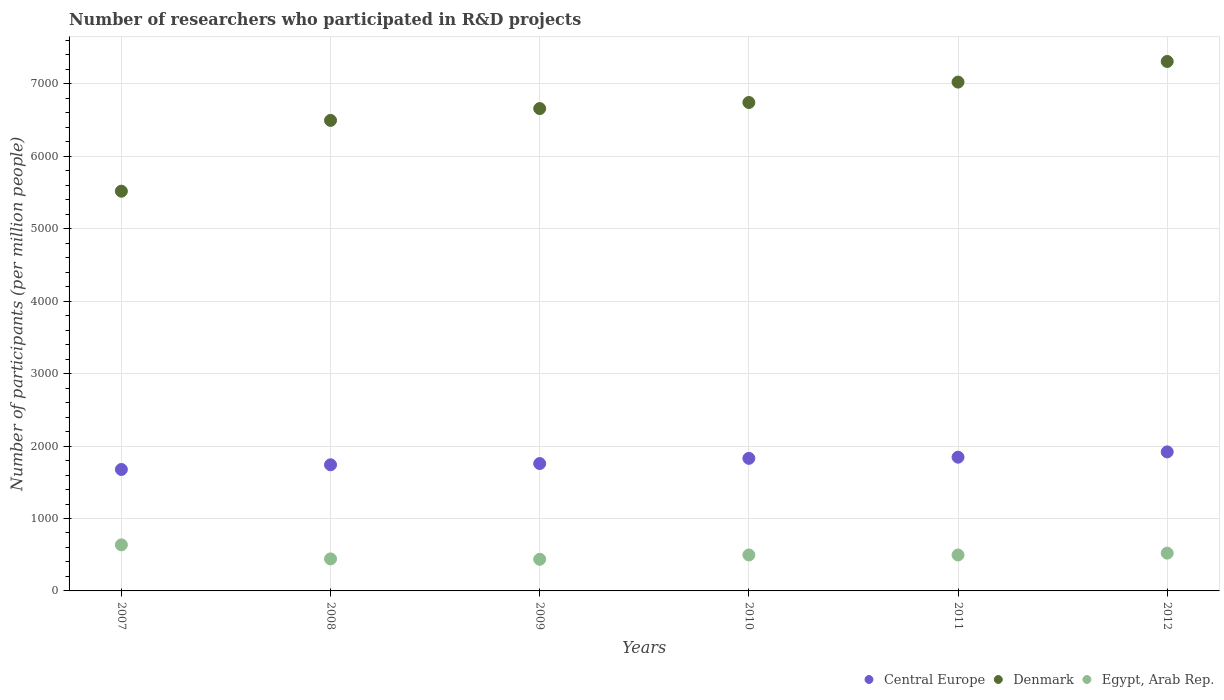Is the number of dotlines equal to the number of legend labels?
Make the answer very short. Yes. What is the number of researchers who participated in R&D projects in Denmark in 2012?
Your response must be concise. 7310.52. Across all years, what is the maximum number of researchers who participated in R&D projects in Denmark?
Provide a short and direct response. 7310.52. Across all years, what is the minimum number of researchers who participated in R&D projects in Denmark?
Give a very brief answer. 5519.32. What is the total number of researchers who participated in R&D projects in Central Europe in the graph?
Ensure brevity in your answer.  1.08e+04. What is the difference between the number of researchers who participated in R&D projects in Egypt, Arab Rep. in 2007 and that in 2009?
Provide a short and direct response. 199.02. What is the difference between the number of researchers who participated in R&D projects in Egypt, Arab Rep. in 2009 and the number of researchers who participated in R&D projects in Central Europe in 2010?
Ensure brevity in your answer.  -1393.5. What is the average number of researchers who participated in R&D projects in Egypt, Arab Rep. per year?
Offer a terse response. 505. In the year 2010, what is the difference between the number of researchers who participated in R&D projects in Central Europe and number of researchers who participated in R&D projects in Egypt, Arab Rep.?
Your answer should be compact. 1333.83. What is the ratio of the number of researchers who participated in R&D projects in Central Europe in 2009 to that in 2011?
Provide a short and direct response. 0.95. What is the difference between the highest and the second highest number of researchers who participated in R&D projects in Egypt, Arab Rep.?
Your answer should be very brief. 114.34. What is the difference between the highest and the lowest number of researchers who participated in R&D projects in Central Europe?
Your response must be concise. 242.64. In how many years, is the number of researchers who participated in R&D projects in Egypt, Arab Rep. greater than the average number of researchers who participated in R&D projects in Egypt, Arab Rep. taken over all years?
Offer a very short reply. 2. Is the sum of the number of researchers who participated in R&D projects in Egypt, Arab Rep. in 2007 and 2011 greater than the maximum number of researchers who participated in R&D projects in Denmark across all years?
Offer a very short reply. No. Is it the case that in every year, the sum of the number of researchers who participated in R&D projects in Egypt, Arab Rep. and number of researchers who participated in R&D projects in Central Europe  is greater than the number of researchers who participated in R&D projects in Denmark?
Your response must be concise. No. Is the number of researchers who participated in R&D projects in Central Europe strictly less than the number of researchers who participated in R&D projects in Denmark over the years?
Your answer should be very brief. Yes. How many dotlines are there?
Offer a very short reply. 3. How many years are there in the graph?
Offer a very short reply. 6. What is the difference between two consecutive major ticks on the Y-axis?
Ensure brevity in your answer.  1000. Does the graph contain grids?
Your response must be concise. Yes. Where does the legend appear in the graph?
Make the answer very short. Bottom right. How are the legend labels stacked?
Make the answer very short. Horizontal. What is the title of the graph?
Offer a very short reply. Number of researchers who participated in R&D projects. Does "Romania" appear as one of the legend labels in the graph?
Give a very brief answer. No. What is the label or title of the Y-axis?
Offer a terse response. Number of participants (per million people). What is the Number of participants (per million people) of Central Europe in 2007?
Your answer should be compact. 1676.99. What is the Number of participants (per million people) of Denmark in 2007?
Offer a terse response. 5519.32. What is the Number of participants (per million people) in Egypt, Arab Rep. in 2007?
Offer a very short reply. 636.08. What is the Number of participants (per million people) of Central Europe in 2008?
Your response must be concise. 1741.84. What is the Number of participants (per million people) of Denmark in 2008?
Offer a terse response. 6496.76. What is the Number of participants (per million people) in Egypt, Arab Rep. in 2008?
Provide a succinct answer. 442.27. What is the Number of participants (per million people) in Central Europe in 2009?
Your response must be concise. 1758.57. What is the Number of participants (per million people) of Denmark in 2009?
Make the answer very short. 6660.14. What is the Number of participants (per million people) of Egypt, Arab Rep. in 2009?
Keep it short and to the point. 437.06. What is the Number of participants (per million people) of Central Europe in 2010?
Make the answer very short. 1830.56. What is the Number of participants (per million people) in Denmark in 2010?
Give a very brief answer. 6743.9. What is the Number of participants (per million people) of Egypt, Arab Rep. in 2010?
Your answer should be very brief. 496.73. What is the Number of participants (per million people) in Central Europe in 2011?
Your response must be concise. 1846.65. What is the Number of participants (per million people) in Denmark in 2011?
Your response must be concise. 7025.82. What is the Number of participants (per million people) in Egypt, Arab Rep. in 2011?
Your answer should be very brief. 496.12. What is the Number of participants (per million people) of Central Europe in 2012?
Your answer should be very brief. 1919.63. What is the Number of participants (per million people) of Denmark in 2012?
Provide a succinct answer. 7310.52. What is the Number of participants (per million people) of Egypt, Arab Rep. in 2012?
Provide a short and direct response. 521.74. Across all years, what is the maximum Number of participants (per million people) of Central Europe?
Provide a short and direct response. 1919.63. Across all years, what is the maximum Number of participants (per million people) in Denmark?
Provide a short and direct response. 7310.52. Across all years, what is the maximum Number of participants (per million people) of Egypt, Arab Rep.?
Your answer should be very brief. 636.08. Across all years, what is the minimum Number of participants (per million people) of Central Europe?
Keep it short and to the point. 1676.99. Across all years, what is the minimum Number of participants (per million people) in Denmark?
Offer a very short reply. 5519.32. Across all years, what is the minimum Number of participants (per million people) in Egypt, Arab Rep.?
Provide a short and direct response. 437.06. What is the total Number of participants (per million people) of Central Europe in the graph?
Ensure brevity in your answer.  1.08e+04. What is the total Number of participants (per million people) of Denmark in the graph?
Provide a succinct answer. 3.98e+04. What is the total Number of participants (per million people) of Egypt, Arab Rep. in the graph?
Ensure brevity in your answer.  3029.99. What is the difference between the Number of participants (per million people) of Central Europe in 2007 and that in 2008?
Your answer should be very brief. -64.85. What is the difference between the Number of participants (per million people) in Denmark in 2007 and that in 2008?
Your answer should be compact. -977.45. What is the difference between the Number of participants (per million people) in Egypt, Arab Rep. in 2007 and that in 2008?
Ensure brevity in your answer.  193.81. What is the difference between the Number of participants (per million people) of Central Europe in 2007 and that in 2009?
Provide a succinct answer. -81.58. What is the difference between the Number of participants (per million people) of Denmark in 2007 and that in 2009?
Your answer should be compact. -1140.83. What is the difference between the Number of participants (per million people) in Egypt, Arab Rep. in 2007 and that in 2009?
Provide a short and direct response. 199.02. What is the difference between the Number of participants (per million people) of Central Europe in 2007 and that in 2010?
Ensure brevity in your answer.  -153.57. What is the difference between the Number of participants (per million people) of Denmark in 2007 and that in 2010?
Ensure brevity in your answer.  -1224.58. What is the difference between the Number of participants (per million people) of Egypt, Arab Rep. in 2007 and that in 2010?
Your response must be concise. 139.35. What is the difference between the Number of participants (per million people) of Central Europe in 2007 and that in 2011?
Ensure brevity in your answer.  -169.66. What is the difference between the Number of participants (per million people) of Denmark in 2007 and that in 2011?
Your answer should be very brief. -1506.5. What is the difference between the Number of participants (per million people) in Egypt, Arab Rep. in 2007 and that in 2011?
Your answer should be very brief. 139.96. What is the difference between the Number of participants (per million people) in Central Europe in 2007 and that in 2012?
Make the answer very short. -242.64. What is the difference between the Number of participants (per million people) in Denmark in 2007 and that in 2012?
Your answer should be compact. -1791.2. What is the difference between the Number of participants (per million people) in Egypt, Arab Rep. in 2007 and that in 2012?
Your answer should be very brief. 114.34. What is the difference between the Number of participants (per million people) in Central Europe in 2008 and that in 2009?
Ensure brevity in your answer.  -16.73. What is the difference between the Number of participants (per million people) of Denmark in 2008 and that in 2009?
Your response must be concise. -163.38. What is the difference between the Number of participants (per million people) of Egypt, Arab Rep. in 2008 and that in 2009?
Offer a terse response. 5.21. What is the difference between the Number of participants (per million people) of Central Europe in 2008 and that in 2010?
Offer a terse response. -88.71. What is the difference between the Number of participants (per million people) of Denmark in 2008 and that in 2010?
Your answer should be very brief. -247.13. What is the difference between the Number of participants (per million people) of Egypt, Arab Rep. in 2008 and that in 2010?
Your answer should be very brief. -54.46. What is the difference between the Number of participants (per million people) of Central Europe in 2008 and that in 2011?
Your response must be concise. -104.8. What is the difference between the Number of participants (per million people) in Denmark in 2008 and that in 2011?
Offer a terse response. -529.05. What is the difference between the Number of participants (per million people) in Egypt, Arab Rep. in 2008 and that in 2011?
Keep it short and to the point. -53.85. What is the difference between the Number of participants (per million people) in Central Europe in 2008 and that in 2012?
Provide a succinct answer. -177.79. What is the difference between the Number of participants (per million people) in Denmark in 2008 and that in 2012?
Provide a succinct answer. -813.75. What is the difference between the Number of participants (per million people) in Egypt, Arab Rep. in 2008 and that in 2012?
Keep it short and to the point. -79.47. What is the difference between the Number of participants (per million people) of Central Europe in 2009 and that in 2010?
Your answer should be compact. -71.98. What is the difference between the Number of participants (per million people) of Denmark in 2009 and that in 2010?
Your answer should be very brief. -83.75. What is the difference between the Number of participants (per million people) of Egypt, Arab Rep. in 2009 and that in 2010?
Keep it short and to the point. -59.67. What is the difference between the Number of participants (per million people) in Central Europe in 2009 and that in 2011?
Offer a terse response. -88.07. What is the difference between the Number of participants (per million people) of Denmark in 2009 and that in 2011?
Make the answer very short. -365.67. What is the difference between the Number of participants (per million people) of Egypt, Arab Rep. in 2009 and that in 2011?
Ensure brevity in your answer.  -59.06. What is the difference between the Number of participants (per million people) in Central Europe in 2009 and that in 2012?
Ensure brevity in your answer.  -161.06. What is the difference between the Number of participants (per million people) in Denmark in 2009 and that in 2012?
Provide a short and direct response. -650.37. What is the difference between the Number of participants (per million people) of Egypt, Arab Rep. in 2009 and that in 2012?
Ensure brevity in your answer.  -84.68. What is the difference between the Number of participants (per million people) in Central Europe in 2010 and that in 2011?
Make the answer very short. -16.09. What is the difference between the Number of participants (per million people) in Denmark in 2010 and that in 2011?
Give a very brief answer. -281.92. What is the difference between the Number of participants (per million people) in Egypt, Arab Rep. in 2010 and that in 2011?
Ensure brevity in your answer.  0.61. What is the difference between the Number of participants (per million people) of Central Europe in 2010 and that in 2012?
Give a very brief answer. -89.08. What is the difference between the Number of participants (per million people) in Denmark in 2010 and that in 2012?
Keep it short and to the point. -566.62. What is the difference between the Number of participants (per million people) of Egypt, Arab Rep. in 2010 and that in 2012?
Keep it short and to the point. -25.01. What is the difference between the Number of participants (per million people) in Central Europe in 2011 and that in 2012?
Offer a terse response. -72.98. What is the difference between the Number of participants (per million people) in Denmark in 2011 and that in 2012?
Provide a short and direct response. -284.7. What is the difference between the Number of participants (per million people) of Egypt, Arab Rep. in 2011 and that in 2012?
Provide a succinct answer. -25.62. What is the difference between the Number of participants (per million people) in Central Europe in 2007 and the Number of participants (per million people) in Denmark in 2008?
Ensure brevity in your answer.  -4819.78. What is the difference between the Number of participants (per million people) of Central Europe in 2007 and the Number of participants (per million people) of Egypt, Arab Rep. in 2008?
Your answer should be very brief. 1234.72. What is the difference between the Number of participants (per million people) of Denmark in 2007 and the Number of participants (per million people) of Egypt, Arab Rep. in 2008?
Offer a very short reply. 5077.05. What is the difference between the Number of participants (per million people) in Central Europe in 2007 and the Number of participants (per million people) in Denmark in 2009?
Keep it short and to the point. -4983.15. What is the difference between the Number of participants (per million people) in Central Europe in 2007 and the Number of participants (per million people) in Egypt, Arab Rep. in 2009?
Your response must be concise. 1239.93. What is the difference between the Number of participants (per million people) of Denmark in 2007 and the Number of participants (per million people) of Egypt, Arab Rep. in 2009?
Offer a terse response. 5082.26. What is the difference between the Number of participants (per million people) of Central Europe in 2007 and the Number of participants (per million people) of Denmark in 2010?
Offer a terse response. -5066.91. What is the difference between the Number of participants (per million people) in Central Europe in 2007 and the Number of participants (per million people) in Egypt, Arab Rep. in 2010?
Offer a terse response. 1180.26. What is the difference between the Number of participants (per million people) of Denmark in 2007 and the Number of participants (per million people) of Egypt, Arab Rep. in 2010?
Give a very brief answer. 5022.59. What is the difference between the Number of participants (per million people) of Central Europe in 2007 and the Number of participants (per million people) of Denmark in 2011?
Your response must be concise. -5348.83. What is the difference between the Number of participants (per million people) of Central Europe in 2007 and the Number of participants (per million people) of Egypt, Arab Rep. in 2011?
Keep it short and to the point. 1180.87. What is the difference between the Number of participants (per million people) in Denmark in 2007 and the Number of participants (per million people) in Egypt, Arab Rep. in 2011?
Your answer should be compact. 5023.2. What is the difference between the Number of participants (per million people) in Central Europe in 2007 and the Number of participants (per million people) in Denmark in 2012?
Your response must be concise. -5633.53. What is the difference between the Number of participants (per million people) of Central Europe in 2007 and the Number of participants (per million people) of Egypt, Arab Rep. in 2012?
Offer a very short reply. 1155.25. What is the difference between the Number of participants (per million people) in Denmark in 2007 and the Number of participants (per million people) in Egypt, Arab Rep. in 2012?
Ensure brevity in your answer.  4997.58. What is the difference between the Number of participants (per million people) of Central Europe in 2008 and the Number of participants (per million people) of Denmark in 2009?
Provide a short and direct response. -4918.3. What is the difference between the Number of participants (per million people) of Central Europe in 2008 and the Number of participants (per million people) of Egypt, Arab Rep. in 2009?
Ensure brevity in your answer.  1304.78. What is the difference between the Number of participants (per million people) in Denmark in 2008 and the Number of participants (per million people) in Egypt, Arab Rep. in 2009?
Make the answer very short. 6059.71. What is the difference between the Number of participants (per million people) in Central Europe in 2008 and the Number of participants (per million people) in Denmark in 2010?
Keep it short and to the point. -5002.06. What is the difference between the Number of participants (per million people) in Central Europe in 2008 and the Number of participants (per million people) in Egypt, Arab Rep. in 2010?
Offer a very short reply. 1245.11. What is the difference between the Number of participants (per million people) in Denmark in 2008 and the Number of participants (per million people) in Egypt, Arab Rep. in 2010?
Ensure brevity in your answer.  6000.03. What is the difference between the Number of participants (per million people) of Central Europe in 2008 and the Number of participants (per million people) of Denmark in 2011?
Offer a terse response. -5283.97. What is the difference between the Number of participants (per million people) in Central Europe in 2008 and the Number of participants (per million people) in Egypt, Arab Rep. in 2011?
Make the answer very short. 1245.73. What is the difference between the Number of participants (per million people) in Denmark in 2008 and the Number of participants (per million people) in Egypt, Arab Rep. in 2011?
Offer a very short reply. 6000.65. What is the difference between the Number of participants (per million people) in Central Europe in 2008 and the Number of participants (per million people) in Denmark in 2012?
Your answer should be very brief. -5568.68. What is the difference between the Number of participants (per million people) of Central Europe in 2008 and the Number of participants (per million people) of Egypt, Arab Rep. in 2012?
Your answer should be very brief. 1220.1. What is the difference between the Number of participants (per million people) of Denmark in 2008 and the Number of participants (per million people) of Egypt, Arab Rep. in 2012?
Make the answer very short. 5975.02. What is the difference between the Number of participants (per million people) in Central Europe in 2009 and the Number of participants (per million people) in Denmark in 2010?
Your answer should be compact. -4985.33. What is the difference between the Number of participants (per million people) in Central Europe in 2009 and the Number of participants (per million people) in Egypt, Arab Rep. in 2010?
Your answer should be compact. 1261.84. What is the difference between the Number of participants (per million people) in Denmark in 2009 and the Number of participants (per million people) in Egypt, Arab Rep. in 2010?
Your answer should be compact. 6163.41. What is the difference between the Number of participants (per million people) in Central Europe in 2009 and the Number of participants (per million people) in Denmark in 2011?
Keep it short and to the point. -5267.24. What is the difference between the Number of participants (per million people) in Central Europe in 2009 and the Number of participants (per million people) in Egypt, Arab Rep. in 2011?
Your answer should be very brief. 1262.46. What is the difference between the Number of participants (per million people) in Denmark in 2009 and the Number of participants (per million people) in Egypt, Arab Rep. in 2011?
Keep it short and to the point. 6164.03. What is the difference between the Number of participants (per million people) of Central Europe in 2009 and the Number of participants (per million people) of Denmark in 2012?
Provide a succinct answer. -5551.94. What is the difference between the Number of participants (per million people) of Central Europe in 2009 and the Number of participants (per million people) of Egypt, Arab Rep. in 2012?
Your answer should be compact. 1236.83. What is the difference between the Number of participants (per million people) of Denmark in 2009 and the Number of participants (per million people) of Egypt, Arab Rep. in 2012?
Provide a short and direct response. 6138.4. What is the difference between the Number of participants (per million people) in Central Europe in 2010 and the Number of participants (per million people) in Denmark in 2011?
Give a very brief answer. -5195.26. What is the difference between the Number of participants (per million people) of Central Europe in 2010 and the Number of participants (per million people) of Egypt, Arab Rep. in 2011?
Your answer should be very brief. 1334.44. What is the difference between the Number of participants (per million people) of Denmark in 2010 and the Number of participants (per million people) of Egypt, Arab Rep. in 2011?
Your answer should be very brief. 6247.78. What is the difference between the Number of participants (per million people) of Central Europe in 2010 and the Number of participants (per million people) of Denmark in 2012?
Provide a short and direct response. -5479.96. What is the difference between the Number of participants (per million people) of Central Europe in 2010 and the Number of participants (per million people) of Egypt, Arab Rep. in 2012?
Your response must be concise. 1308.82. What is the difference between the Number of participants (per million people) in Denmark in 2010 and the Number of participants (per million people) in Egypt, Arab Rep. in 2012?
Give a very brief answer. 6222.16. What is the difference between the Number of participants (per million people) of Central Europe in 2011 and the Number of participants (per million people) of Denmark in 2012?
Your answer should be very brief. -5463.87. What is the difference between the Number of participants (per million people) in Central Europe in 2011 and the Number of participants (per million people) in Egypt, Arab Rep. in 2012?
Your answer should be compact. 1324.91. What is the difference between the Number of participants (per million people) of Denmark in 2011 and the Number of participants (per million people) of Egypt, Arab Rep. in 2012?
Give a very brief answer. 6504.08. What is the average Number of participants (per million people) of Central Europe per year?
Give a very brief answer. 1795.71. What is the average Number of participants (per million people) of Denmark per year?
Provide a succinct answer. 6626.08. What is the average Number of participants (per million people) in Egypt, Arab Rep. per year?
Your answer should be compact. 505. In the year 2007, what is the difference between the Number of participants (per million people) of Central Europe and Number of participants (per million people) of Denmark?
Offer a terse response. -3842.33. In the year 2007, what is the difference between the Number of participants (per million people) of Central Europe and Number of participants (per million people) of Egypt, Arab Rep.?
Provide a short and direct response. 1040.91. In the year 2007, what is the difference between the Number of participants (per million people) in Denmark and Number of participants (per million people) in Egypt, Arab Rep.?
Provide a short and direct response. 4883.24. In the year 2008, what is the difference between the Number of participants (per million people) in Central Europe and Number of participants (per million people) in Denmark?
Your answer should be very brief. -4754.92. In the year 2008, what is the difference between the Number of participants (per million people) in Central Europe and Number of participants (per million people) in Egypt, Arab Rep.?
Provide a short and direct response. 1299.57. In the year 2008, what is the difference between the Number of participants (per million people) of Denmark and Number of participants (per million people) of Egypt, Arab Rep.?
Give a very brief answer. 6054.49. In the year 2009, what is the difference between the Number of participants (per million people) in Central Europe and Number of participants (per million people) in Denmark?
Provide a succinct answer. -4901.57. In the year 2009, what is the difference between the Number of participants (per million people) of Central Europe and Number of participants (per million people) of Egypt, Arab Rep.?
Ensure brevity in your answer.  1321.51. In the year 2009, what is the difference between the Number of participants (per million people) of Denmark and Number of participants (per million people) of Egypt, Arab Rep.?
Keep it short and to the point. 6223.09. In the year 2010, what is the difference between the Number of participants (per million people) of Central Europe and Number of participants (per million people) of Denmark?
Make the answer very short. -4913.34. In the year 2010, what is the difference between the Number of participants (per million people) of Central Europe and Number of participants (per million people) of Egypt, Arab Rep.?
Provide a short and direct response. 1333.83. In the year 2010, what is the difference between the Number of participants (per million people) of Denmark and Number of participants (per million people) of Egypt, Arab Rep.?
Provide a short and direct response. 6247.17. In the year 2011, what is the difference between the Number of participants (per million people) in Central Europe and Number of participants (per million people) in Denmark?
Give a very brief answer. -5179.17. In the year 2011, what is the difference between the Number of participants (per million people) in Central Europe and Number of participants (per million people) in Egypt, Arab Rep.?
Offer a very short reply. 1350.53. In the year 2011, what is the difference between the Number of participants (per million people) of Denmark and Number of participants (per million people) of Egypt, Arab Rep.?
Give a very brief answer. 6529.7. In the year 2012, what is the difference between the Number of participants (per million people) of Central Europe and Number of participants (per million people) of Denmark?
Ensure brevity in your answer.  -5390.89. In the year 2012, what is the difference between the Number of participants (per million people) of Central Europe and Number of participants (per million people) of Egypt, Arab Rep.?
Ensure brevity in your answer.  1397.89. In the year 2012, what is the difference between the Number of participants (per million people) of Denmark and Number of participants (per million people) of Egypt, Arab Rep.?
Provide a succinct answer. 6788.78. What is the ratio of the Number of participants (per million people) in Central Europe in 2007 to that in 2008?
Give a very brief answer. 0.96. What is the ratio of the Number of participants (per million people) of Denmark in 2007 to that in 2008?
Offer a very short reply. 0.85. What is the ratio of the Number of participants (per million people) of Egypt, Arab Rep. in 2007 to that in 2008?
Give a very brief answer. 1.44. What is the ratio of the Number of participants (per million people) in Central Europe in 2007 to that in 2009?
Offer a terse response. 0.95. What is the ratio of the Number of participants (per million people) of Denmark in 2007 to that in 2009?
Make the answer very short. 0.83. What is the ratio of the Number of participants (per million people) of Egypt, Arab Rep. in 2007 to that in 2009?
Give a very brief answer. 1.46. What is the ratio of the Number of participants (per million people) in Central Europe in 2007 to that in 2010?
Your response must be concise. 0.92. What is the ratio of the Number of participants (per million people) in Denmark in 2007 to that in 2010?
Your answer should be compact. 0.82. What is the ratio of the Number of participants (per million people) of Egypt, Arab Rep. in 2007 to that in 2010?
Give a very brief answer. 1.28. What is the ratio of the Number of participants (per million people) of Central Europe in 2007 to that in 2011?
Your response must be concise. 0.91. What is the ratio of the Number of participants (per million people) in Denmark in 2007 to that in 2011?
Provide a succinct answer. 0.79. What is the ratio of the Number of participants (per million people) in Egypt, Arab Rep. in 2007 to that in 2011?
Provide a succinct answer. 1.28. What is the ratio of the Number of participants (per million people) in Central Europe in 2007 to that in 2012?
Keep it short and to the point. 0.87. What is the ratio of the Number of participants (per million people) of Denmark in 2007 to that in 2012?
Your answer should be compact. 0.76. What is the ratio of the Number of participants (per million people) of Egypt, Arab Rep. in 2007 to that in 2012?
Keep it short and to the point. 1.22. What is the ratio of the Number of participants (per million people) of Central Europe in 2008 to that in 2009?
Offer a terse response. 0.99. What is the ratio of the Number of participants (per million people) in Denmark in 2008 to that in 2009?
Provide a short and direct response. 0.98. What is the ratio of the Number of participants (per million people) of Egypt, Arab Rep. in 2008 to that in 2009?
Provide a short and direct response. 1.01. What is the ratio of the Number of participants (per million people) in Central Europe in 2008 to that in 2010?
Provide a short and direct response. 0.95. What is the ratio of the Number of participants (per million people) in Denmark in 2008 to that in 2010?
Keep it short and to the point. 0.96. What is the ratio of the Number of participants (per million people) in Egypt, Arab Rep. in 2008 to that in 2010?
Ensure brevity in your answer.  0.89. What is the ratio of the Number of participants (per million people) of Central Europe in 2008 to that in 2011?
Your answer should be compact. 0.94. What is the ratio of the Number of participants (per million people) in Denmark in 2008 to that in 2011?
Offer a terse response. 0.92. What is the ratio of the Number of participants (per million people) of Egypt, Arab Rep. in 2008 to that in 2011?
Your answer should be compact. 0.89. What is the ratio of the Number of participants (per million people) in Central Europe in 2008 to that in 2012?
Your answer should be very brief. 0.91. What is the ratio of the Number of participants (per million people) in Denmark in 2008 to that in 2012?
Make the answer very short. 0.89. What is the ratio of the Number of participants (per million people) of Egypt, Arab Rep. in 2008 to that in 2012?
Your response must be concise. 0.85. What is the ratio of the Number of participants (per million people) in Central Europe in 2009 to that in 2010?
Offer a very short reply. 0.96. What is the ratio of the Number of participants (per million people) in Denmark in 2009 to that in 2010?
Keep it short and to the point. 0.99. What is the ratio of the Number of participants (per million people) of Egypt, Arab Rep. in 2009 to that in 2010?
Your answer should be very brief. 0.88. What is the ratio of the Number of participants (per million people) in Central Europe in 2009 to that in 2011?
Your response must be concise. 0.95. What is the ratio of the Number of participants (per million people) in Denmark in 2009 to that in 2011?
Provide a succinct answer. 0.95. What is the ratio of the Number of participants (per million people) in Egypt, Arab Rep. in 2009 to that in 2011?
Offer a very short reply. 0.88. What is the ratio of the Number of participants (per million people) of Central Europe in 2009 to that in 2012?
Make the answer very short. 0.92. What is the ratio of the Number of participants (per million people) of Denmark in 2009 to that in 2012?
Your answer should be compact. 0.91. What is the ratio of the Number of participants (per million people) in Egypt, Arab Rep. in 2009 to that in 2012?
Offer a terse response. 0.84. What is the ratio of the Number of participants (per million people) of Central Europe in 2010 to that in 2011?
Make the answer very short. 0.99. What is the ratio of the Number of participants (per million people) in Denmark in 2010 to that in 2011?
Your response must be concise. 0.96. What is the ratio of the Number of participants (per million people) of Central Europe in 2010 to that in 2012?
Ensure brevity in your answer.  0.95. What is the ratio of the Number of participants (per million people) of Denmark in 2010 to that in 2012?
Make the answer very short. 0.92. What is the ratio of the Number of participants (per million people) in Egypt, Arab Rep. in 2010 to that in 2012?
Your answer should be compact. 0.95. What is the ratio of the Number of participants (per million people) of Central Europe in 2011 to that in 2012?
Make the answer very short. 0.96. What is the ratio of the Number of participants (per million people) in Denmark in 2011 to that in 2012?
Give a very brief answer. 0.96. What is the ratio of the Number of participants (per million people) in Egypt, Arab Rep. in 2011 to that in 2012?
Ensure brevity in your answer.  0.95. What is the difference between the highest and the second highest Number of participants (per million people) in Central Europe?
Provide a short and direct response. 72.98. What is the difference between the highest and the second highest Number of participants (per million people) of Denmark?
Provide a succinct answer. 284.7. What is the difference between the highest and the second highest Number of participants (per million people) of Egypt, Arab Rep.?
Provide a short and direct response. 114.34. What is the difference between the highest and the lowest Number of participants (per million people) in Central Europe?
Keep it short and to the point. 242.64. What is the difference between the highest and the lowest Number of participants (per million people) of Denmark?
Keep it short and to the point. 1791.2. What is the difference between the highest and the lowest Number of participants (per million people) in Egypt, Arab Rep.?
Your answer should be compact. 199.02. 